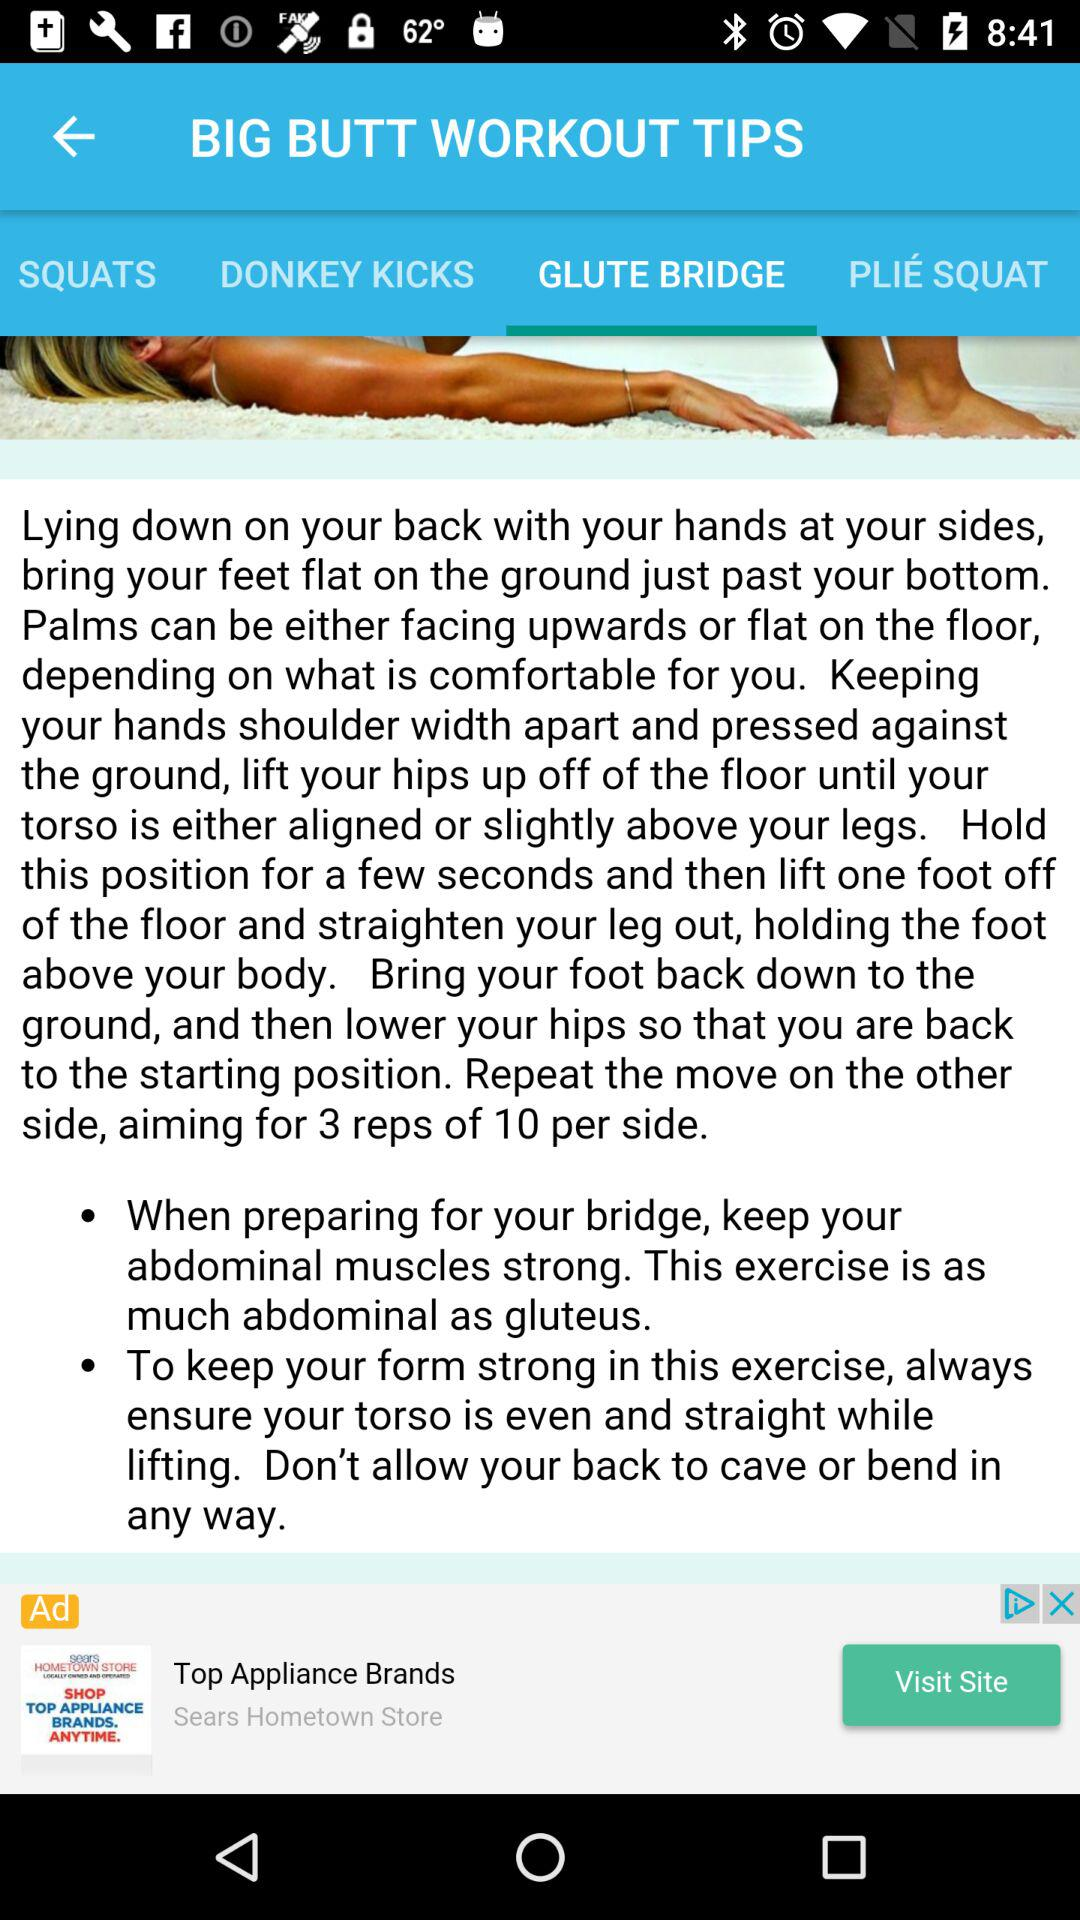How many exercises are there in this workout?
Answer the question using a single word or phrase. 4 